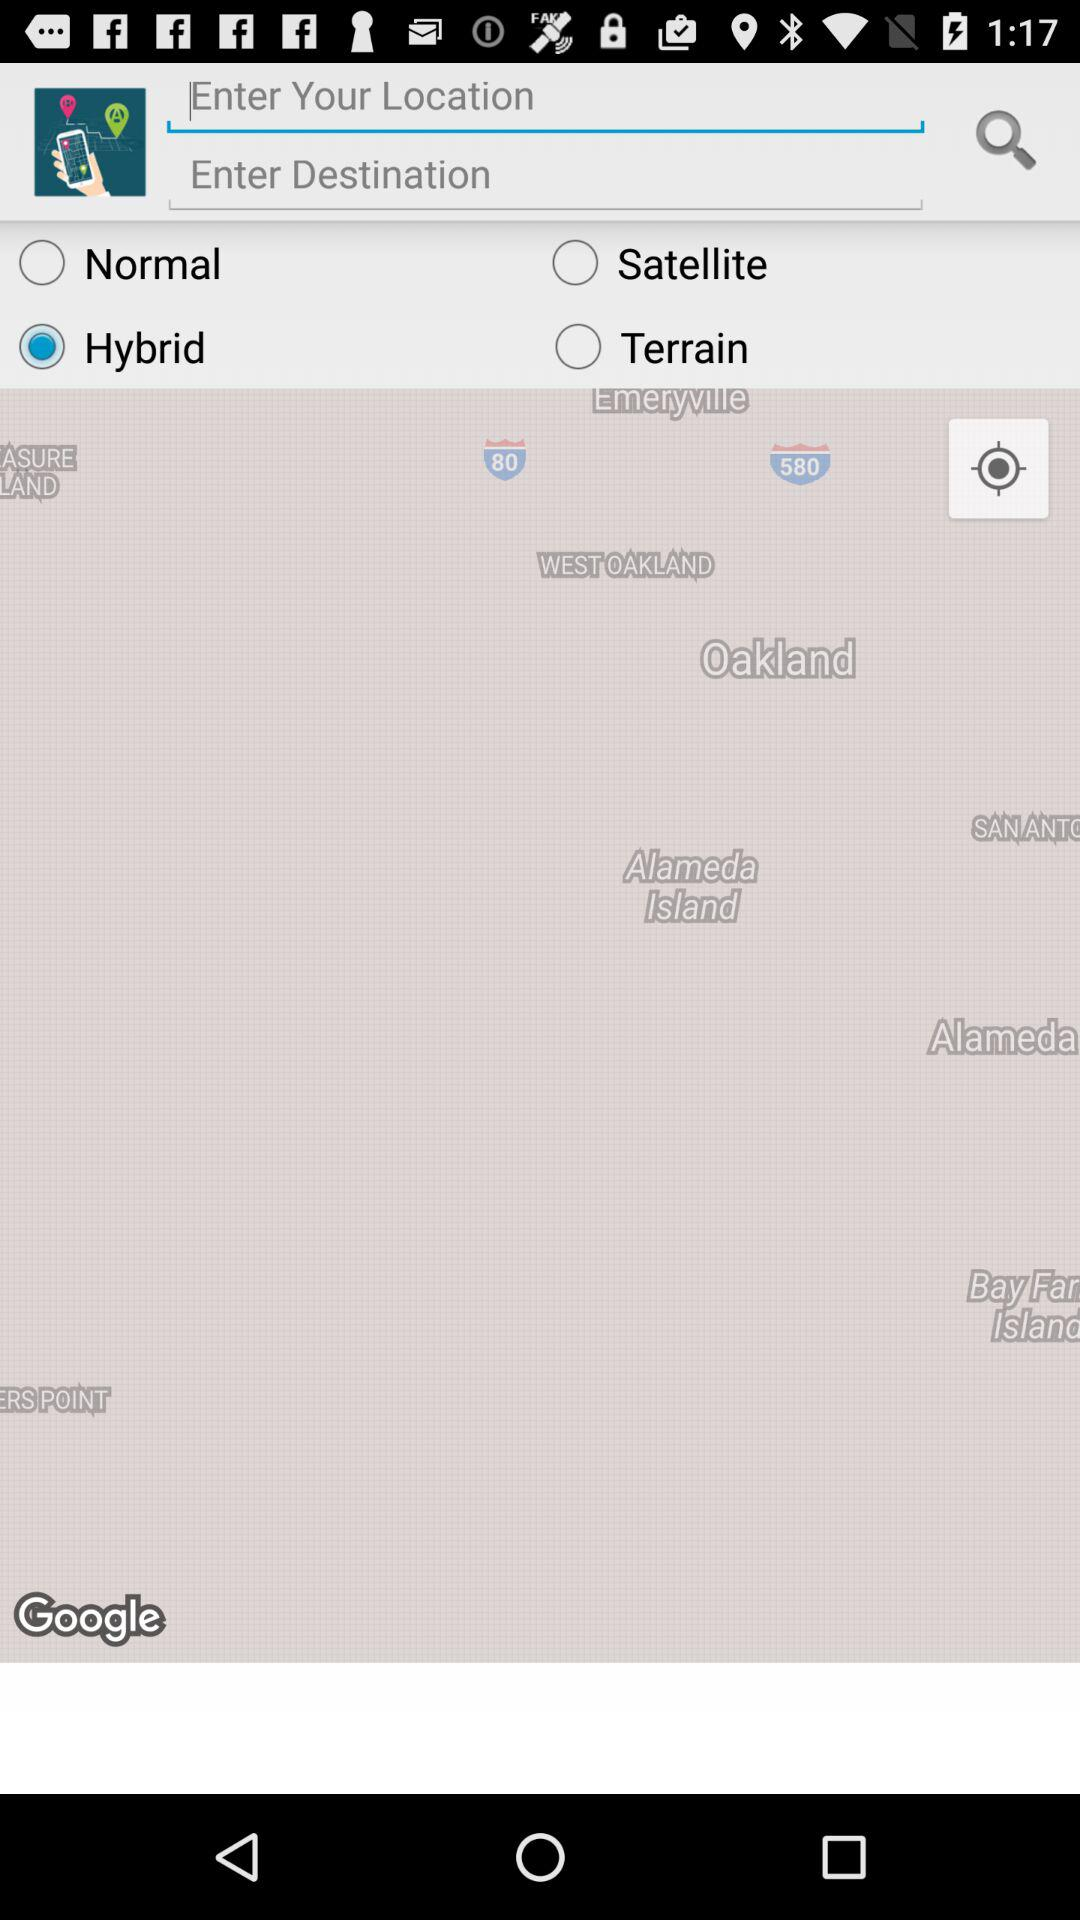What is the status of "Normal"? The status is "off". 